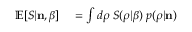Convert formula to latex. <formula><loc_0><loc_0><loc_500><loc_500>\begin{array} { r l } { \mathbb { E } [ S | { n } , \beta ] } & = \int d \rho \, S ( \rho | \beta ) \, p ( \rho | { n } ) } \end{array}</formula> 